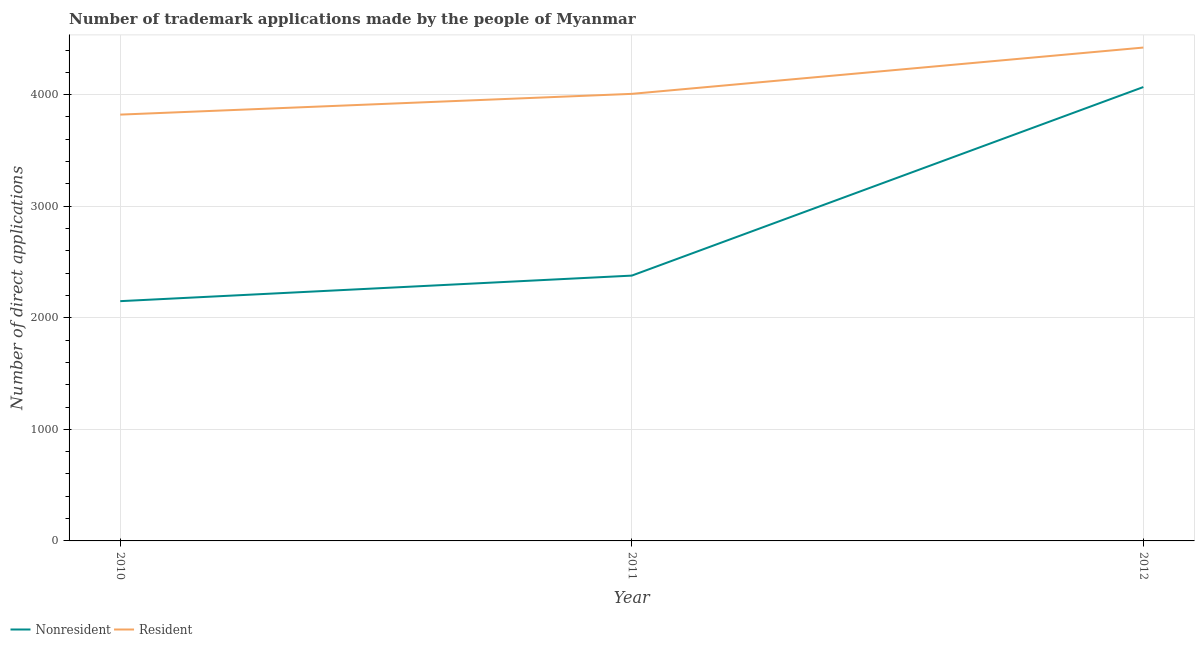Is the number of lines equal to the number of legend labels?
Ensure brevity in your answer.  Yes. What is the number of trademark applications made by residents in 2012?
Your answer should be compact. 4422. Across all years, what is the maximum number of trademark applications made by residents?
Ensure brevity in your answer.  4422. Across all years, what is the minimum number of trademark applications made by non residents?
Your answer should be very brief. 2149. In which year was the number of trademark applications made by non residents maximum?
Offer a terse response. 2012. In which year was the number of trademark applications made by residents minimum?
Offer a terse response. 2010. What is the total number of trademark applications made by residents in the graph?
Ensure brevity in your answer.  1.22e+04. What is the difference between the number of trademark applications made by residents in 2011 and that in 2012?
Make the answer very short. -415. What is the difference between the number of trademark applications made by non residents in 2010 and the number of trademark applications made by residents in 2011?
Ensure brevity in your answer.  -1858. What is the average number of trademark applications made by non residents per year?
Give a very brief answer. 2865. In the year 2011, what is the difference between the number of trademark applications made by non residents and number of trademark applications made by residents?
Ensure brevity in your answer.  -1629. In how many years, is the number of trademark applications made by non residents greater than 3200?
Your answer should be very brief. 1. What is the ratio of the number of trademark applications made by residents in 2010 to that in 2011?
Make the answer very short. 0.95. Is the number of trademark applications made by non residents in 2011 less than that in 2012?
Give a very brief answer. Yes. Is the difference between the number of trademark applications made by non residents in 2010 and 2011 greater than the difference between the number of trademark applications made by residents in 2010 and 2011?
Your response must be concise. No. What is the difference between the highest and the second highest number of trademark applications made by residents?
Your answer should be very brief. 415. What is the difference between the highest and the lowest number of trademark applications made by residents?
Your answer should be very brief. 601. Is the sum of the number of trademark applications made by residents in 2010 and 2011 greater than the maximum number of trademark applications made by non residents across all years?
Your answer should be very brief. Yes. Does the number of trademark applications made by non residents monotonically increase over the years?
Give a very brief answer. Yes. Is the number of trademark applications made by non residents strictly greater than the number of trademark applications made by residents over the years?
Your response must be concise. No. Is the number of trademark applications made by non residents strictly less than the number of trademark applications made by residents over the years?
Your answer should be very brief. Yes. How many years are there in the graph?
Your response must be concise. 3. Does the graph contain any zero values?
Keep it short and to the point. No. Does the graph contain grids?
Keep it short and to the point. Yes. How many legend labels are there?
Give a very brief answer. 2. What is the title of the graph?
Provide a succinct answer. Number of trademark applications made by the people of Myanmar. What is the label or title of the X-axis?
Your answer should be compact. Year. What is the label or title of the Y-axis?
Ensure brevity in your answer.  Number of direct applications. What is the Number of direct applications of Nonresident in 2010?
Keep it short and to the point. 2149. What is the Number of direct applications in Resident in 2010?
Provide a short and direct response. 3821. What is the Number of direct applications of Nonresident in 2011?
Keep it short and to the point. 2378. What is the Number of direct applications of Resident in 2011?
Your response must be concise. 4007. What is the Number of direct applications in Nonresident in 2012?
Make the answer very short. 4068. What is the Number of direct applications in Resident in 2012?
Give a very brief answer. 4422. Across all years, what is the maximum Number of direct applications of Nonresident?
Offer a terse response. 4068. Across all years, what is the maximum Number of direct applications of Resident?
Provide a short and direct response. 4422. Across all years, what is the minimum Number of direct applications of Nonresident?
Your answer should be very brief. 2149. Across all years, what is the minimum Number of direct applications in Resident?
Provide a succinct answer. 3821. What is the total Number of direct applications of Nonresident in the graph?
Provide a succinct answer. 8595. What is the total Number of direct applications of Resident in the graph?
Provide a succinct answer. 1.22e+04. What is the difference between the Number of direct applications of Nonresident in 2010 and that in 2011?
Ensure brevity in your answer.  -229. What is the difference between the Number of direct applications of Resident in 2010 and that in 2011?
Make the answer very short. -186. What is the difference between the Number of direct applications in Nonresident in 2010 and that in 2012?
Offer a terse response. -1919. What is the difference between the Number of direct applications in Resident in 2010 and that in 2012?
Your response must be concise. -601. What is the difference between the Number of direct applications of Nonresident in 2011 and that in 2012?
Your answer should be very brief. -1690. What is the difference between the Number of direct applications in Resident in 2011 and that in 2012?
Make the answer very short. -415. What is the difference between the Number of direct applications of Nonresident in 2010 and the Number of direct applications of Resident in 2011?
Provide a succinct answer. -1858. What is the difference between the Number of direct applications in Nonresident in 2010 and the Number of direct applications in Resident in 2012?
Your response must be concise. -2273. What is the difference between the Number of direct applications in Nonresident in 2011 and the Number of direct applications in Resident in 2012?
Your response must be concise. -2044. What is the average Number of direct applications of Nonresident per year?
Give a very brief answer. 2865. What is the average Number of direct applications of Resident per year?
Your answer should be compact. 4083.33. In the year 2010, what is the difference between the Number of direct applications of Nonresident and Number of direct applications of Resident?
Offer a terse response. -1672. In the year 2011, what is the difference between the Number of direct applications in Nonresident and Number of direct applications in Resident?
Make the answer very short. -1629. In the year 2012, what is the difference between the Number of direct applications in Nonresident and Number of direct applications in Resident?
Provide a short and direct response. -354. What is the ratio of the Number of direct applications in Nonresident in 2010 to that in 2011?
Your response must be concise. 0.9. What is the ratio of the Number of direct applications in Resident in 2010 to that in 2011?
Offer a terse response. 0.95. What is the ratio of the Number of direct applications in Nonresident in 2010 to that in 2012?
Keep it short and to the point. 0.53. What is the ratio of the Number of direct applications of Resident in 2010 to that in 2012?
Your answer should be compact. 0.86. What is the ratio of the Number of direct applications of Nonresident in 2011 to that in 2012?
Give a very brief answer. 0.58. What is the ratio of the Number of direct applications in Resident in 2011 to that in 2012?
Offer a very short reply. 0.91. What is the difference between the highest and the second highest Number of direct applications in Nonresident?
Offer a very short reply. 1690. What is the difference between the highest and the second highest Number of direct applications in Resident?
Ensure brevity in your answer.  415. What is the difference between the highest and the lowest Number of direct applications in Nonresident?
Your response must be concise. 1919. What is the difference between the highest and the lowest Number of direct applications of Resident?
Keep it short and to the point. 601. 